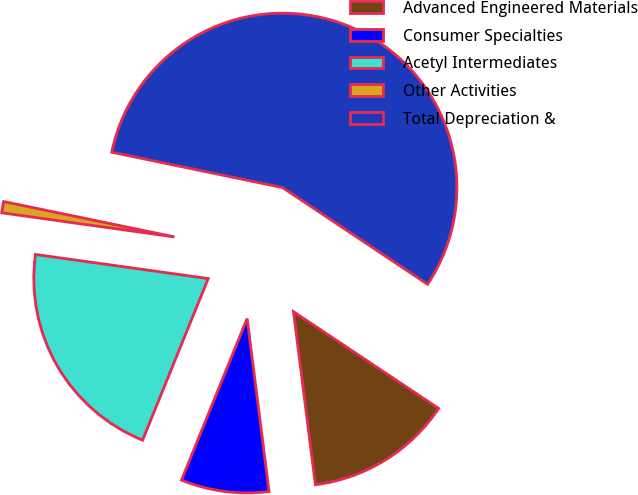<chart> <loc_0><loc_0><loc_500><loc_500><pie_chart><fcel>Advanced Engineered Materials<fcel>Consumer Specialties<fcel>Acetyl Intermediates<fcel>Other Activities<fcel>Total Depreciation &<nl><fcel>13.64%<fcel>8.14%<fcel>21.07%<fcel>1.04%<fcel>56.11%<nl></chart> 